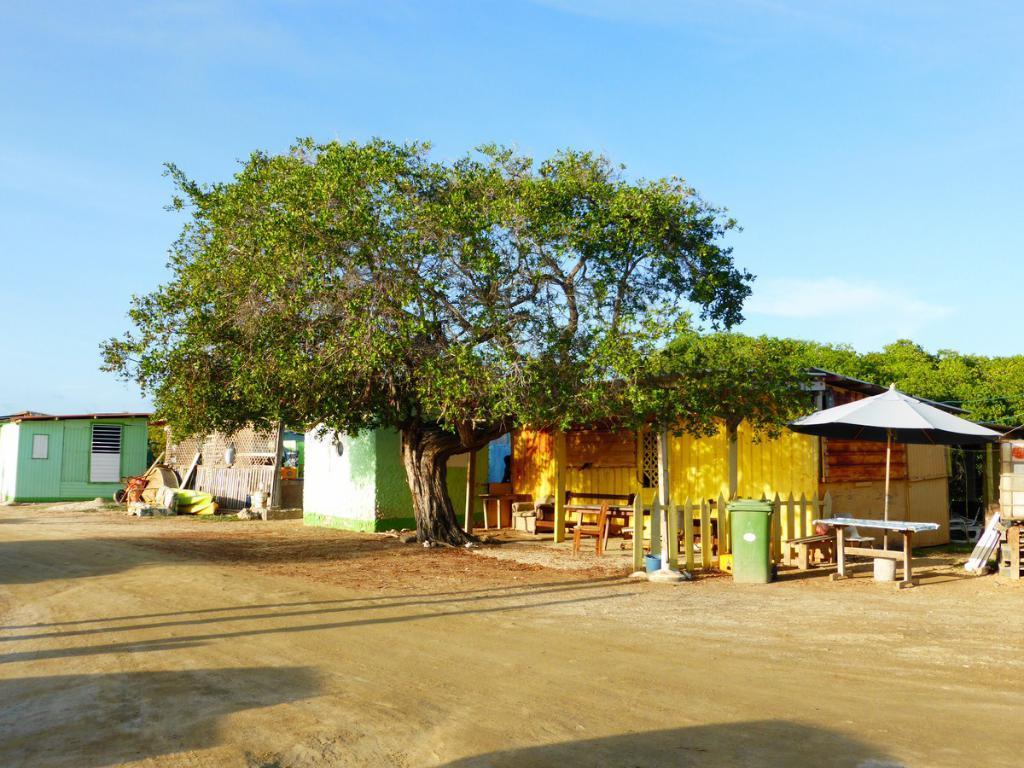Could you give a brief overview of what you see in this image? In this picture we can see the sheds, chairs, tables, fencing, trees, umbrella, rods, benches, wall and some objects. At the bottom of the image we can see the ground. At the top of the image we can see the clouds are present in the sky. 